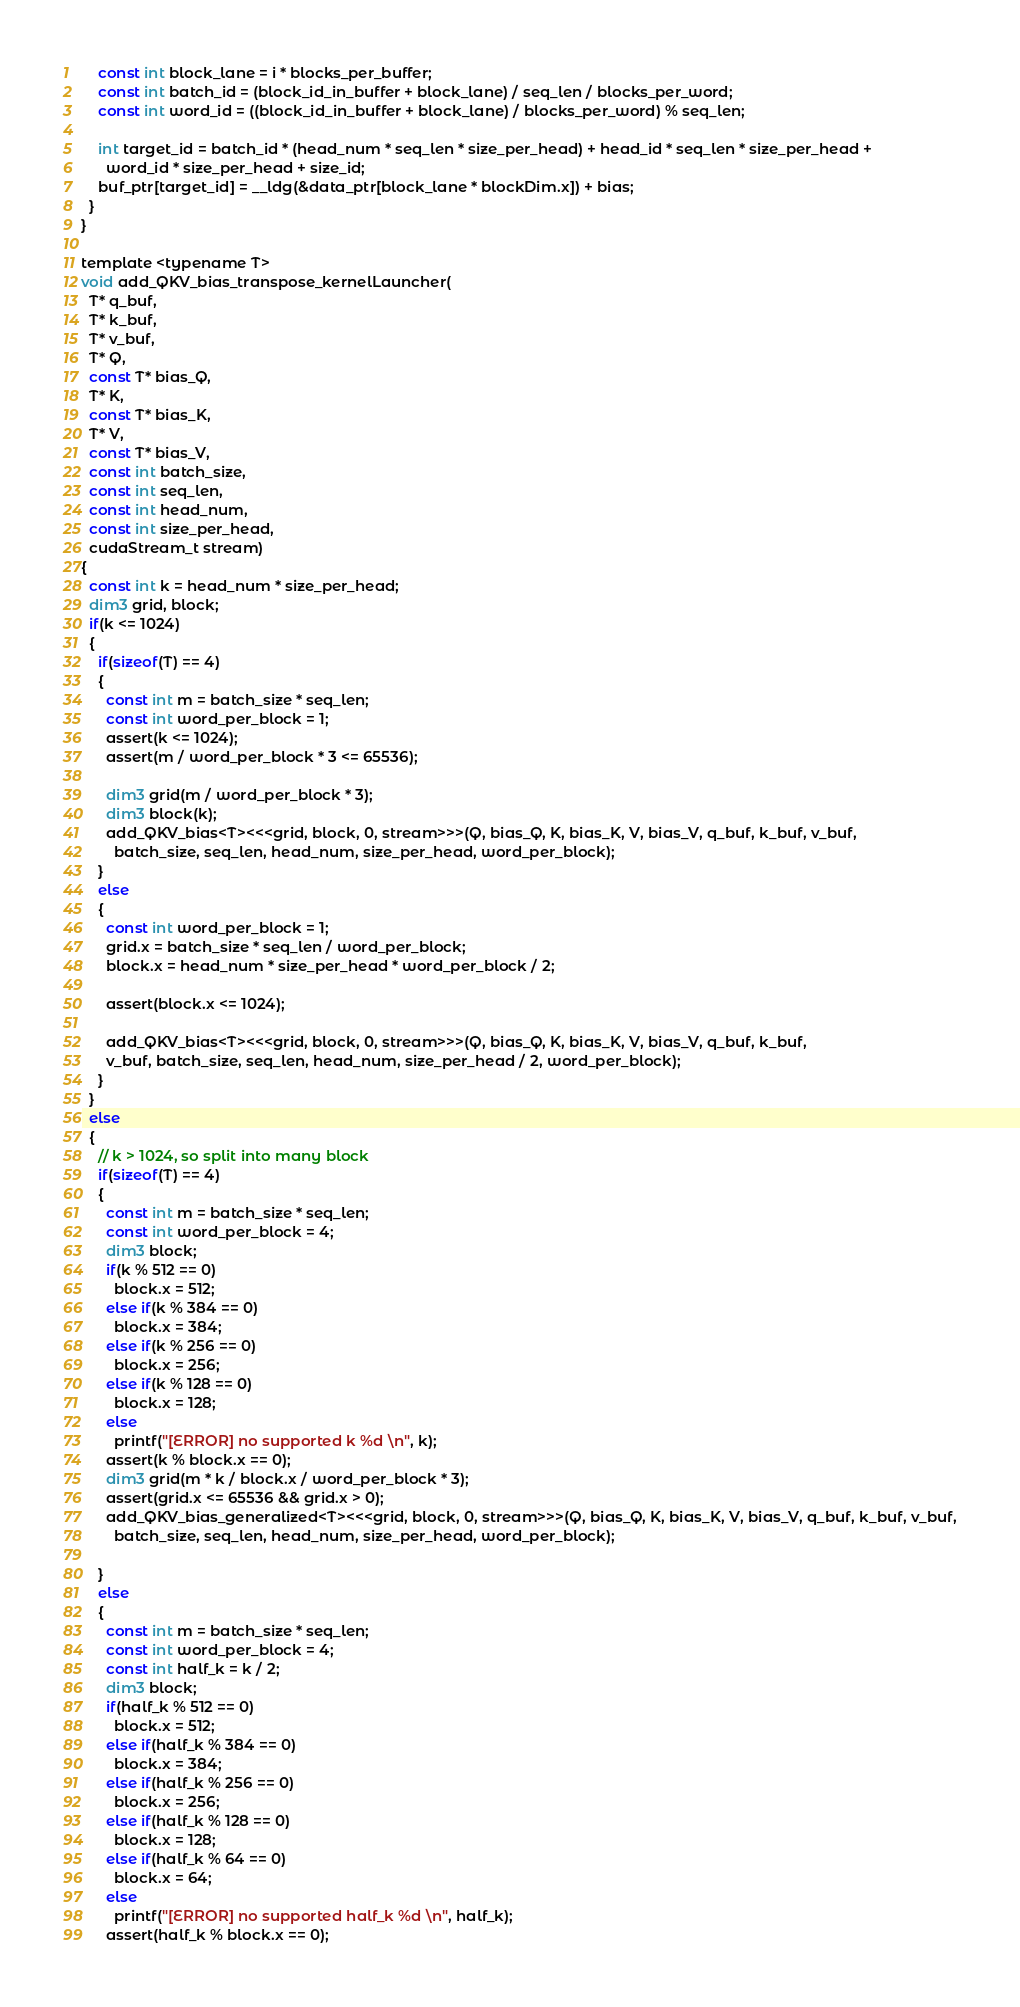<code> <loc_0><loc_0><loc_500><loc_500><_Cuda_>    const int block_lane = i * blocks_per_buffer;
    const int batch_id = (block_id_in_buffer + block_lane) / seq_len / blocks_per_word;
    const int word_id = ((block_id_in_buffer + block_lane) / blocks_per_word) % seq_len;

    int target_id = batch_id * (head_num * seq_len * size_per_head) + head_id * seq_len * size_per_head +
      word_id * size_per_head + size_id;
    buf_ptr[target_id] = __ldg(&data_ptr[block_lane * blockDim.x]) + bias;
  }
}

template <typename T>
void add_QKV_bias_transpose_kernelLauncher(
  T* q_buf,
  T* k_buf,
  T* v_buf,
  T* Q,
  const T* bias_Q,
  T* K,
  const T* bias_K,
  T* V,
  const T* bias_V,
  const int batch_size,
  const int seq_len,
  const int head_num,
  const int size_per_head,
  cudaStream_t stream)
{
  const int k = head_num * size_per_head;
  dim3 grid, block;
  if(k <= 1024)
  {
    if(sizeof(T) == 4)
    {
      const int m = batch_size * seq_len;
      const int word_per_block = 1;
      assert(k <= 1024);
      assert(m / word_per_block * 3 <= 65536);

      dim3 grid(m / word_per_block * 3);
      dim3 block(k);
      add_QKV_bias<T><<<grid, block, 0, stream>>>(Q, bias_Q, K, bias_K, V, bias_V, q_buf, k_buf, v_buf,
        batch_size, seq_len, head_num, size_per_head, word_per_block);
    }
    else
    {
      const int word_per_block = 1;
      grid.x = batch_size * seq_len / word_per_block;
      block.x = head_num * size_per_head * word_per_block / 2;

      assert(block.x <= 1024);

      add_QKV_bias<T><<<grid, block, 0, stream>>>(Q, bias_Q, K, bias_K, V, bias_V, q_buf, k_buf, 
      v_buf, batch_size, seq_len, head_num, size_per_head / 2, word_per_block);
    }
  }
  else
  {
    // k > 1024, so split into many block
    if(sizeof(T) == 4)
    {
      const int m = batch_size * seq_len;
      const int word_per_block = 4;
      dim3 block;
      if(k % 512 == 0)
        block.x = 512;
      else if(k % 384 == 0)
        block.x = 384;
      else if(k % 256 == 0)
        block.x = 256;
      else if(k % 128 == 0)
        block.x = 128;
      else
        printf("[ERROR] no supported k %d \n", k);
      assert(k % block.x == 0);
      dim3 grid(m * k / block.x / word_per_block * 3);
      assert(grid.x <= 65536 && grid.x > 0);
      add_QKV_bias_generalized<T><<<grid, block, 0, stream>>>(Q, bias_Q, K, bias_K, V, bias_V, q_buf, k_buf, v_buf,
        batch_size, seq_len, head_num, size_per_head, word_per_block);

    }
    else
    {
      const int m = batch_size * seq_len;
      const int word_per_block = 4;
      const int half_k = k / 2;
      dim3 block;
      if(half_k % 512 == 0)
        block.x = 512;
      else if(half_k % 384 == 0)
        block.x = 384;
      else if(half_k % 256 == 0)
        block.x = 256;
      else if(half_k % 128 == 0)
        block.x = 128;
      else if(half_k % 64 == 0)
        block.x = 64;
      else
        printf("[ERROR] no supported half_k %d \n", half_k);
      assert(half_k % block.x == 0);</code> 